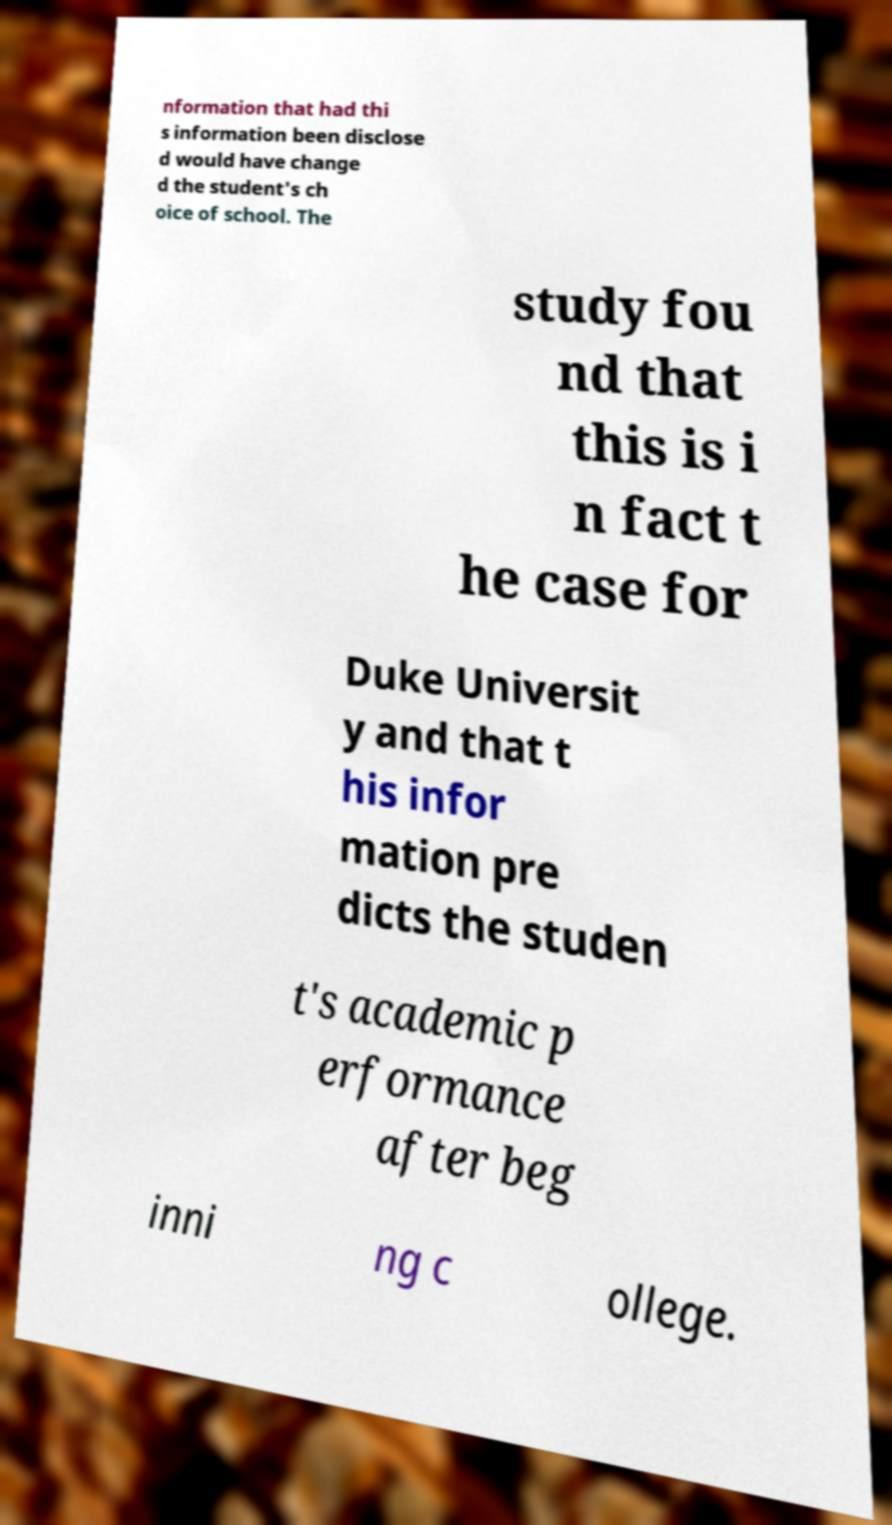Can you read and provide the text displayed in the image?This photo seems to have some interesting text. Can you extract and type it out for me? nformation that had thi s information been disclose d would have change d the student's ch oice of school. The study fou nd that this is i n fact t he case for Duke Universit y and that t his infor mation pre dicts the studen t's academic p erformance after beg inni ng c ollege. 